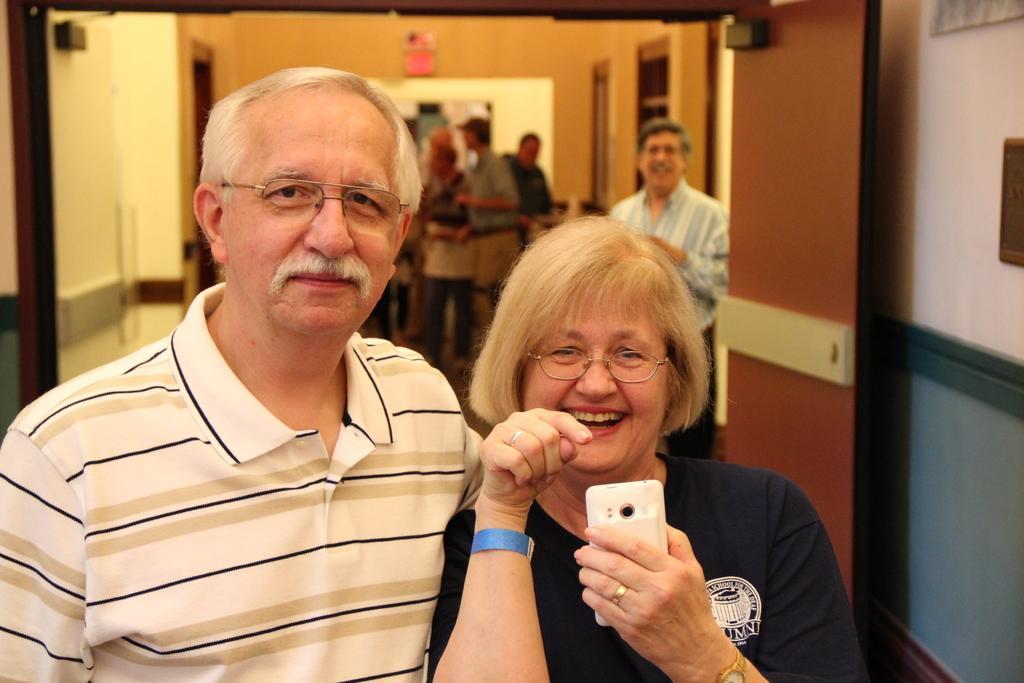How would you summarize this image in a sentence or two? This picture consists of two persons and a woman holding a mobile, she is smiling visible in the foreground, in the background I can see group of persons , one person standing in front of the wall. 